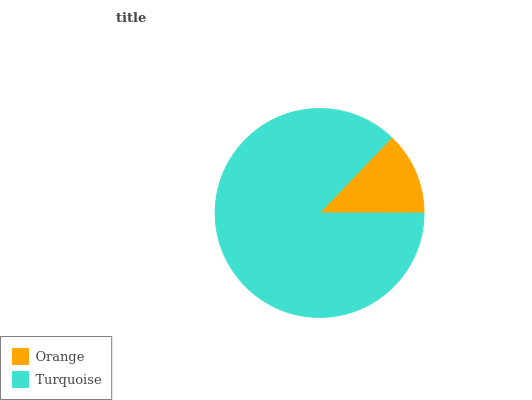Is Orange the minimum?
Answer yes or no. Yes. Is Turquoise the maximum?
Answer yes or no. Yes. Is Turquoise the minimum?
Answer yes or no. No. Is Turquoise greater than Orange?
Answer yes or no. Yes. Is Orange less than Turquoise?
Answer yes or no. Yes. Is Orange greater than Turquoise?
Answer yes or no. No. Is Turquoise less than Orange?
Answer yes or no. No. Is Turquoise the high median?
Answer yes or no. Yes. Is Orange the low median?
Answer yes or no. Yes. Is Orange the high median?
Answer yes or no. No. Is Turquoise the low median?
Answer yes or no. No. 